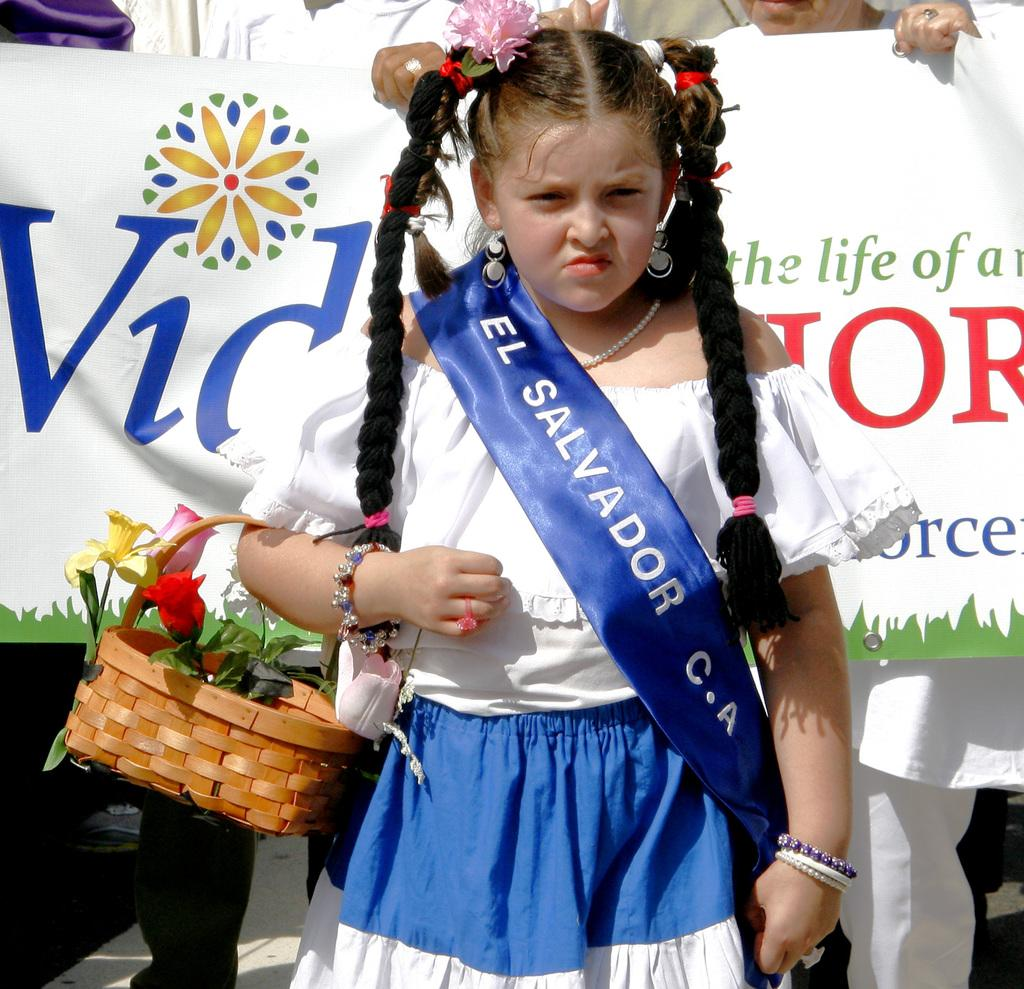<image>
Share a concise interpretation of the image provided. A young girl carrying a basket with flowers wearing a stripe that says EL SALVADOR. 